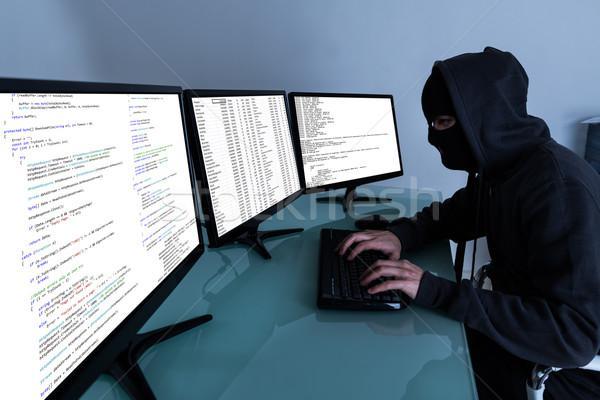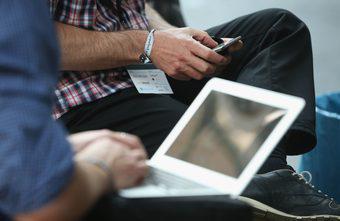The first image is the image on the left, the second image is the image on the right. For the images displayed, is the sentence "a masked man is viewing 3 monitors on a desk" factually correct? Answer yes or no. Yes. The first image is the image on the left, the second image is the image on the right. Analyze the images presented: Is the assertion "In the left image, there's a man in a mask and hoodie typing on a keyboard with three monitors." valid? Answer yes or no. Yes. 